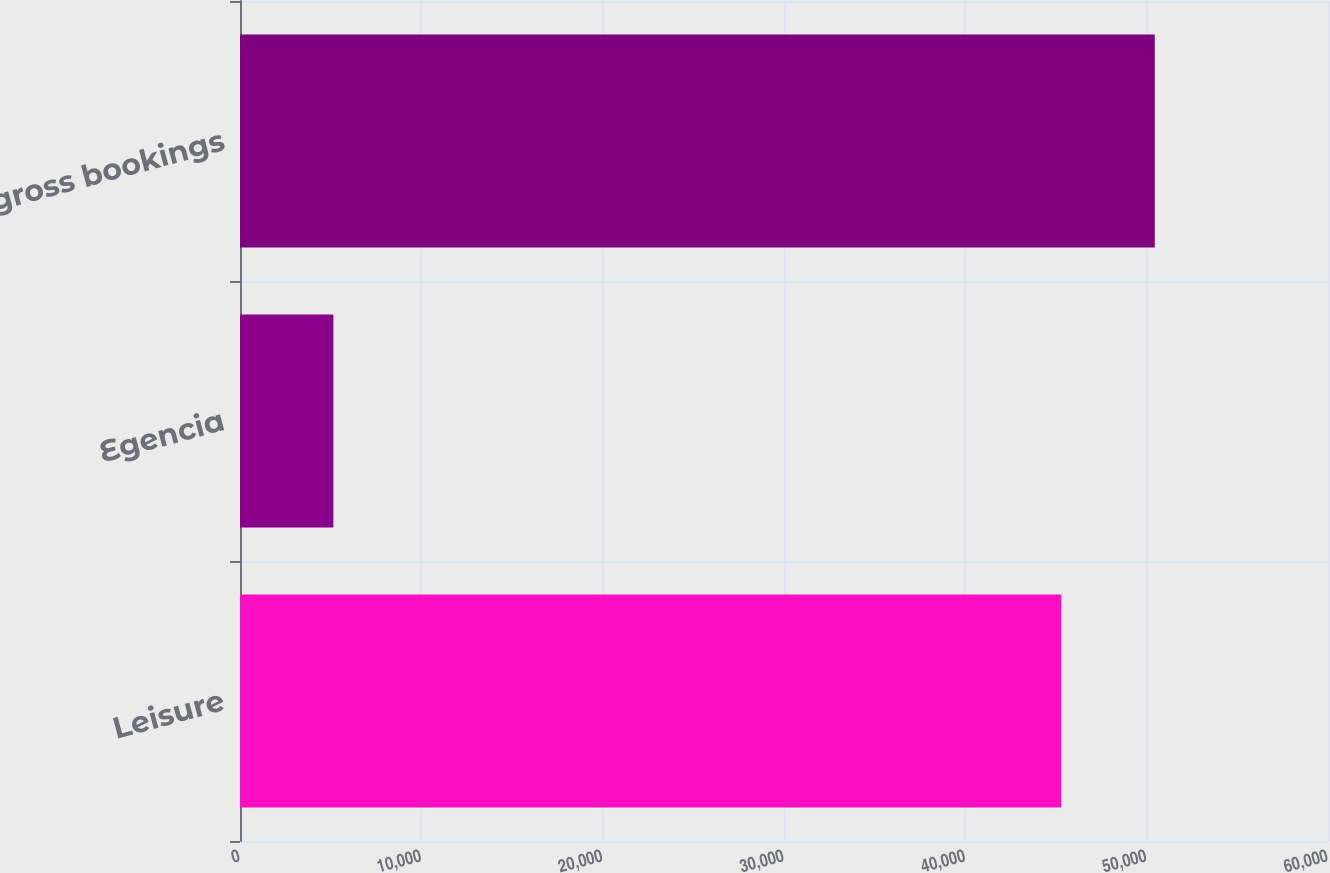Convert chart. <chart><loc_0><loc_0><loc_500><loc_500><bar_chart><fcel>Leisure<fcel>Egencia<fcel>Total gross bookings<nl><fcel>45298<fcel>5149<fcel>50447<nl></chart> 